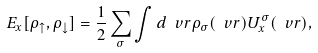Convert formula to latex. <formula><loc_0><loc_0><loc_500><loc_500>E _ { x } [ \rho _ { \uparrow } , \rho _ { \downarrow } ] = \frac { 1 } { 2 } \sum _ { \sigma } \int d \ v r \rho _ { \sigma } ( \ v r ) U ^ { \sigma } _ { x } ( \ v r ) ,</formula> 